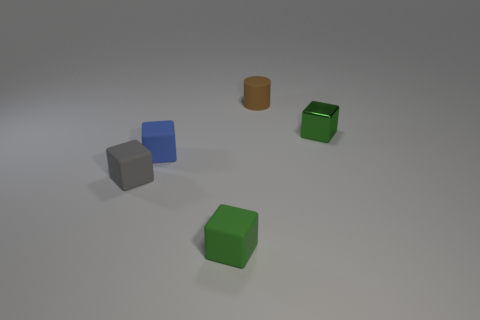Are there any reflective surfaces or materials visible? The surfaces of the objects exhibit a certain level of reflectivity, as indicated by the subtle highlights and the manner in which they interact with the light. The flooring also reflects some light, suggesting it might be made of a semi-glossy material. 